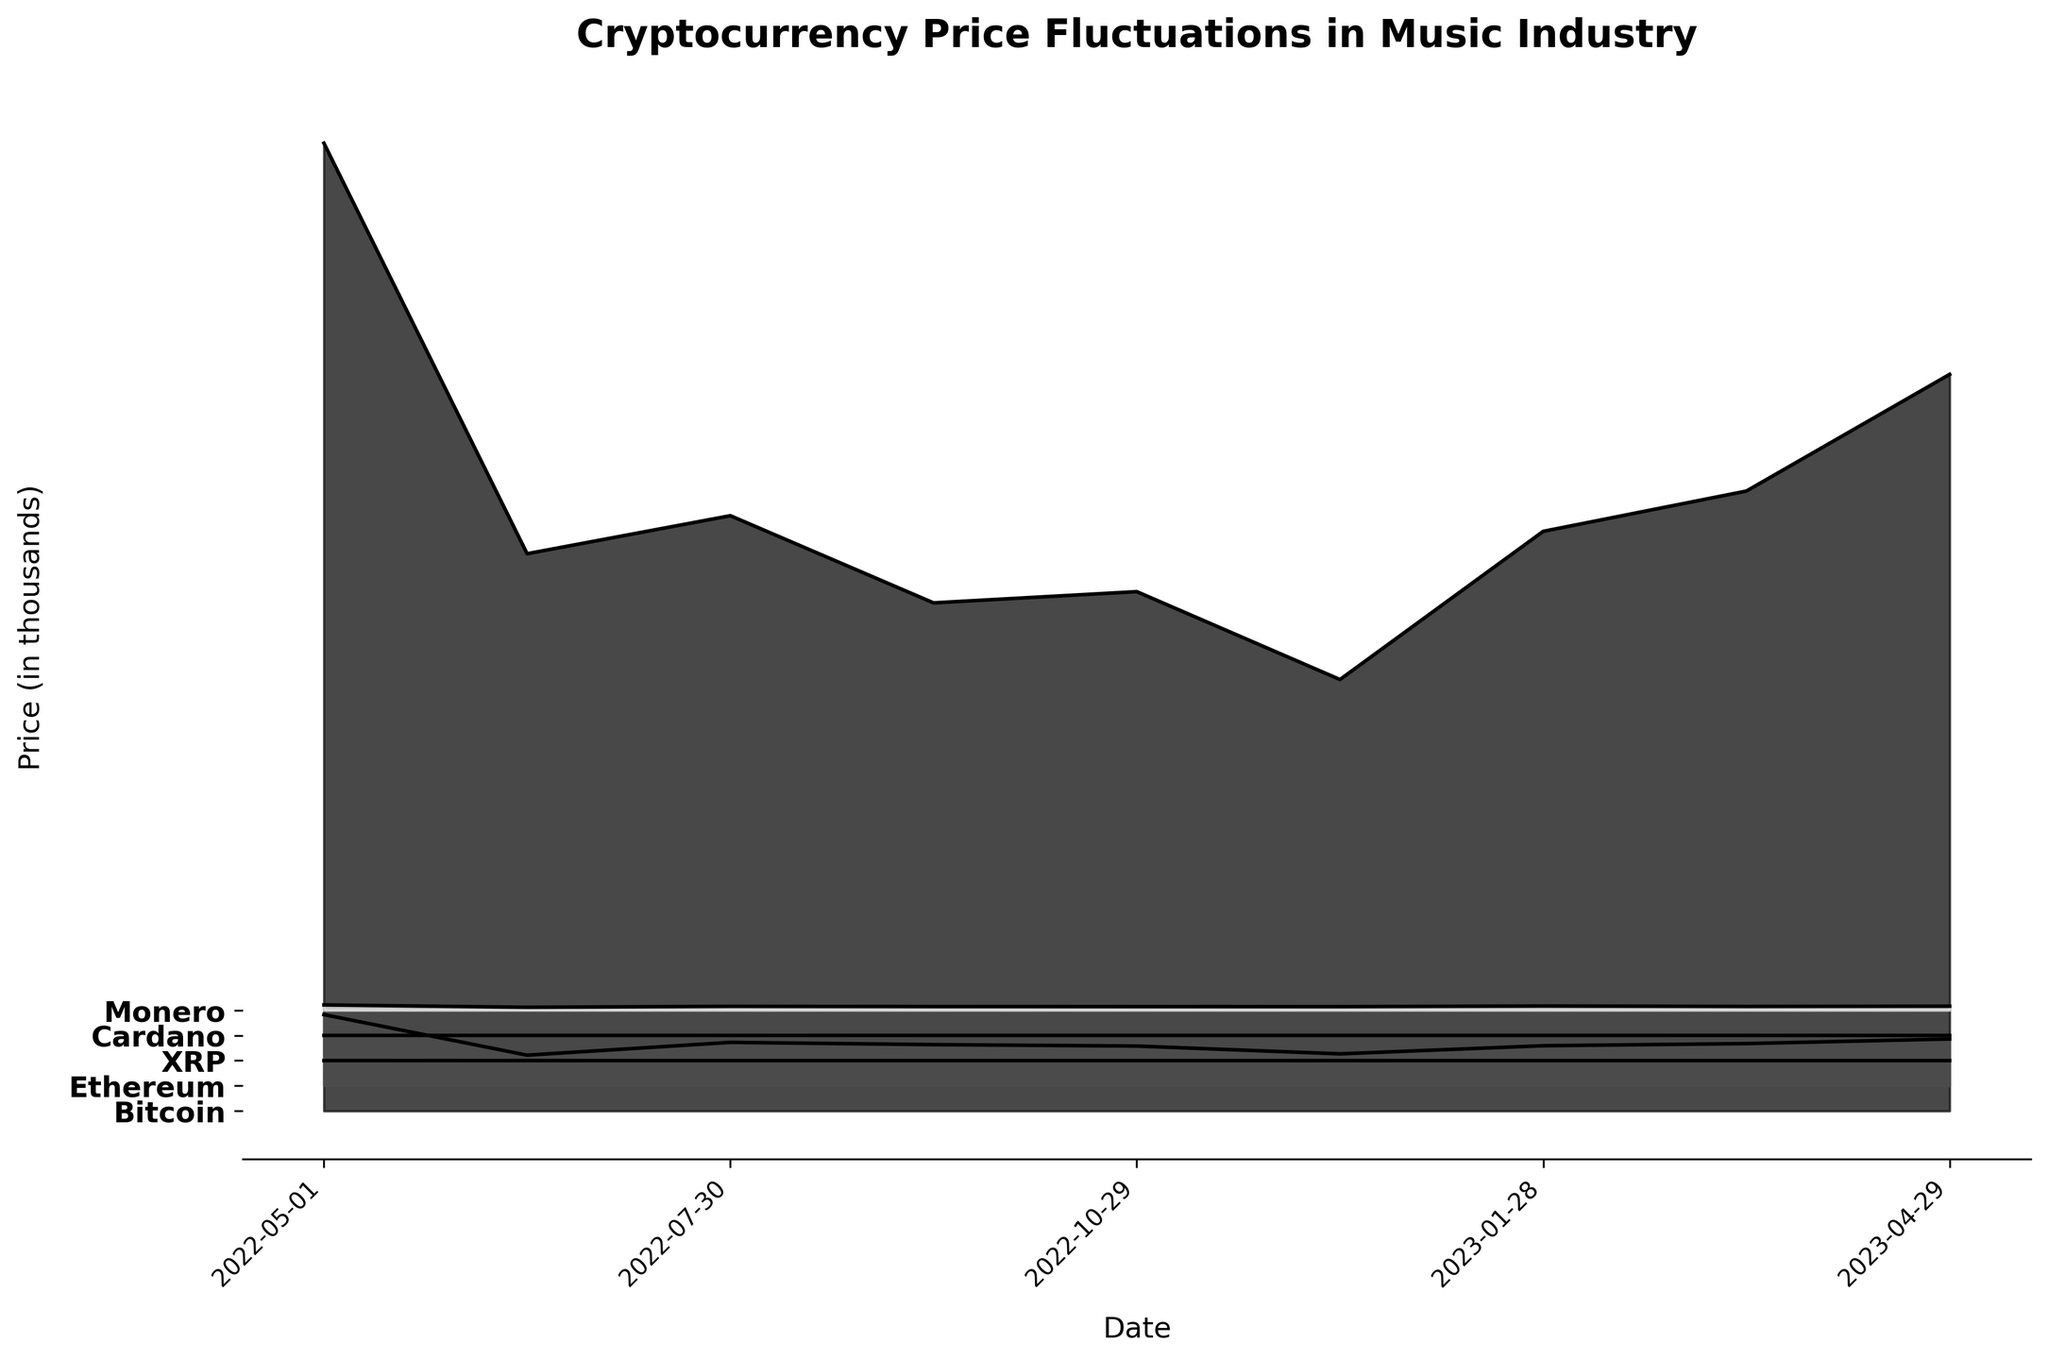What's the title of the plot? The title of the plot can be read at the top of the image. It is written in a bold and larger font, which makes it easy to identify.
Answer: Cryptocurrency Price Fluctuations in Music Industry How many cryptocurrencies are depicted in the plot? By looking at the y-axis, we can see the labels for different cryptocurrencies. Count the number of labels to find the total number of cryptocurrencies depicted in the plot.
Answer: Five Which cryptocurrency showed the most significant price variation over the past year? By observing the height and fluctuation of the lines and filled areas for each cryptocurrency, we can identify which one had the most significant variation. Bitcoin’s line fluctuates the most widely, indicating the highest price variation.
Answer: Bitcoin What was the price of Ethereum in early January 2023? Look at the plot around the date ‘2023-01-28’ on the x-axis. Trace the value of Ethereum (middle line) at this point. The value is above the 1.5 mark approximately.
Answer: Around 1591 On which date did Monero have the lowest price? By tracing the Monero line (the fifth line from bottom) to its lowest point, and matching it to the corresponding date on the x-axis, we can identify the date. The lowest point for Monero is the 6th data point, which corresponds to '2022-06-15.'
Answer: 2022-06-15 Compare the price of Cardano in December 2022 to its price in April 2023. Which one is higher? Locate the points of December 2022 (‘2022-12-13’) and April 2023 (‘2023-04-29’) on the x-axis. Compare the height of the Cardano line (the fourth line from bottom) at these points. Cardano’s line is higher at ‘2023-04-29’ than ‘2022-12-13’.
Answer: April 2023 Which two cryptocurrencies had almost the same price in April 2023? Look at the April 2023 (last data point) on the x-axis and observe the y-values of the lines corresponding to each cryptocurrency. XRP and Monero have nearly the same price as their lines converge closely at the same level.
Answer: XRP and Monero What trend can be observed for Bitcoin over the entire period? Trace the Bitcoin line (top line) from May 2022 to April 2023. There is a noticeable dip in mid-2022 and then a gradual rise towards the end of the period. This indicates an initial fall followed by recovery.
Answer: Initial fall, then gradual recovery Calculate the average price of Cardano across all the dates. Sum the prices of Cardano for each date and divide by the number of data points. Sum = 0.78 + 0.47 + 0.51 + 0.49 + 0.40 + 0.31 + 0.38 + 0.33 + 0.39 = 4.06, divide by 9.
Answer: Approximately 0.45 